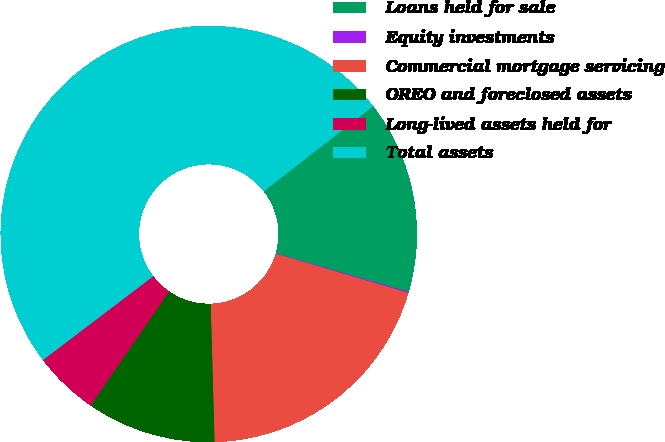<chart> <loc_0><loc_0><loc_500><loc_500><pie_chart><fcel>Loans held for sale<fcel>Equity investments<fcel>Commercial mortgage servicing<fcel>OREO and foreclosed assets<fcel>Long-lived assets held for<fcel>Total assets<nl><fcel>15.01%<fcel>0.09%<fcel>19.98%<fcel>10.04%<fcel>5.06%<fcel>49.82%<nl></chart> 